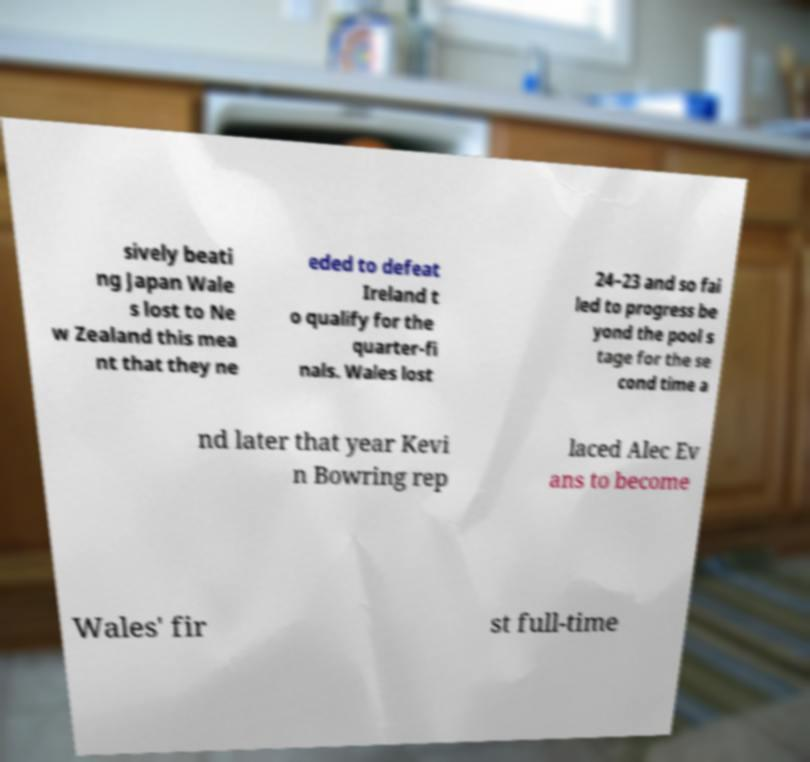Could you assist in decoding the text presented in this image and type it out clearly? sively beati ng Japan Wale s lost to Ne w Zealand this mea nt that they ne eded to defeat Ireland t o qualify for the quarter-fi nals. Wales lost 24–23 and so fai led to progress be yond the pool s tage for the se cond time a nd later that year Kevi n Bowring rep laced Alec Ev ans to become Wales' fir st full-time 